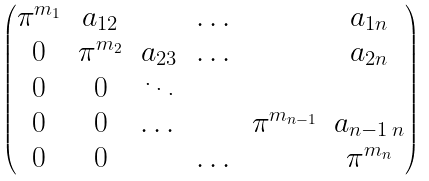Convert formula to latex. <formula><loc_0><loc_0><loc_500><loc_500>\begin{pmatrix} \pi ^ { m _ { 1 } } & a _ { 1 2 } & & \dots & & a _ { 1 n } \\ 0 & \pi ^ { m _ { 2 } } & a _ { 2 3 } & \dots & & a _ { 2 n } \\ 0 & 0 & \ddots & & \\ 0 & 0 & \dots & & \pi ^ { m _ { n - 1 } } & a _ { n - 1 \, n } \\ 0 & 0 & & \dots & & \pi ^ { m _ { n } } \end{pmatrix}</formula> 